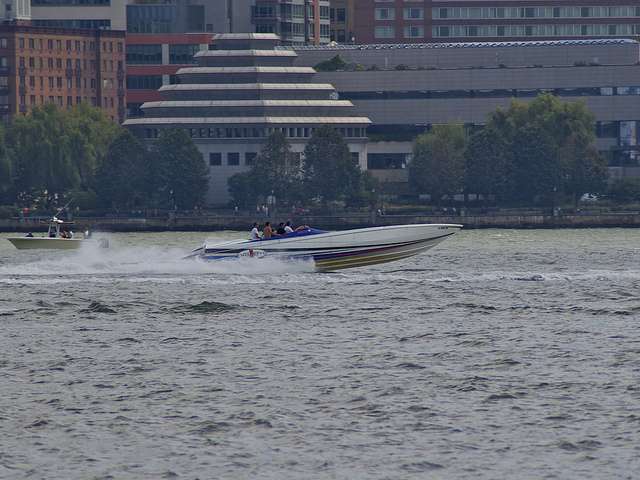<image>What kind of hat is the man on the boat wearing? I don't know what kind of hat the man on the boat is wearing. He might not be wearing a hat or he might be wearing a baseball cap. What kind of hat is the man on the boat wearing? It is ambiguous what kind of hat the man on the boat is wearing. It can be seen 'baseball cap', 'baseball' or 'ball cap'. 